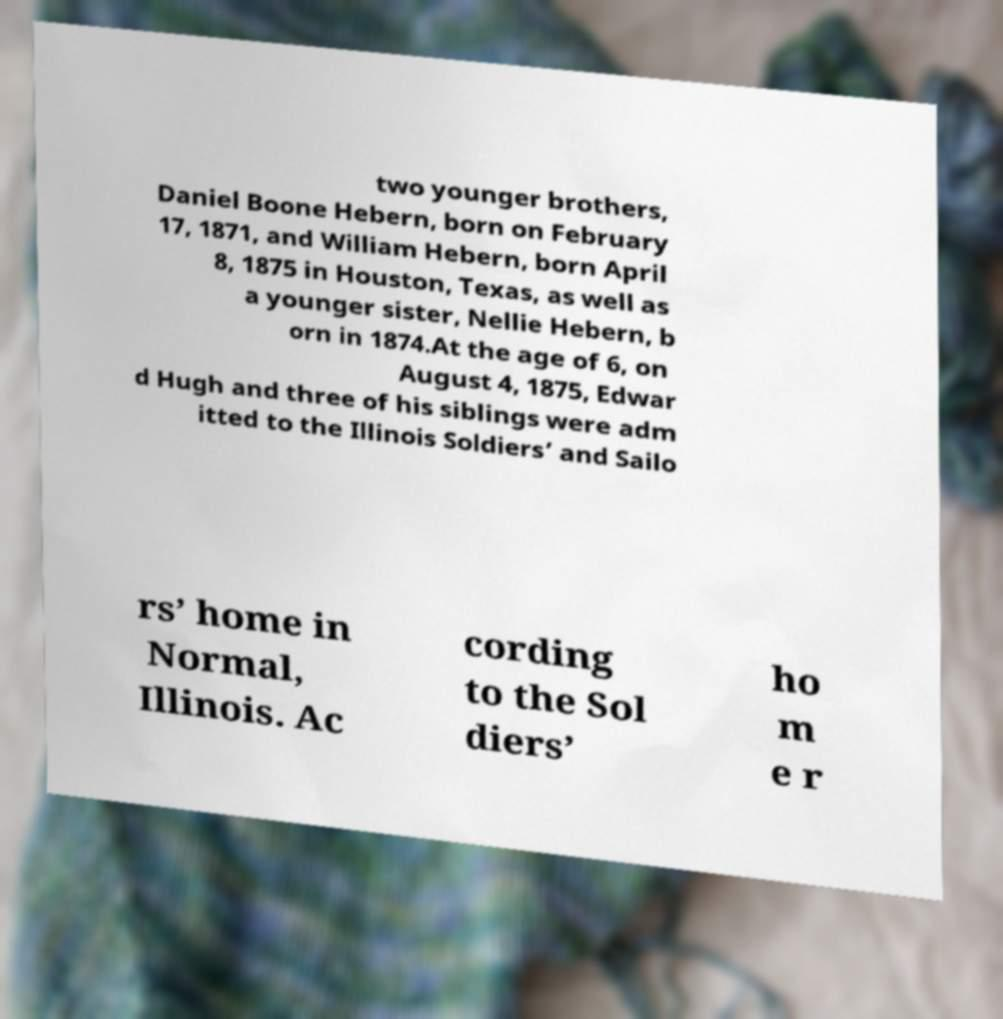Please identify and transcribe the text found in this image. two younger brothers, Daniel Boone Hebern, born on February 17, 1871, and William Hebern, born April 8, 1875 in Houston, Texas, as well as a younger sister, Nellie Hebern, b orn in 1874.At the age of 6, on August 4, 1875, Edwar d Hugh and three of his siblings were adm itted to the Illinois Soldiers’ and Sailo rs’ home in Normal, Illinois. Ac cording to the Sol diers’ ho m e r 